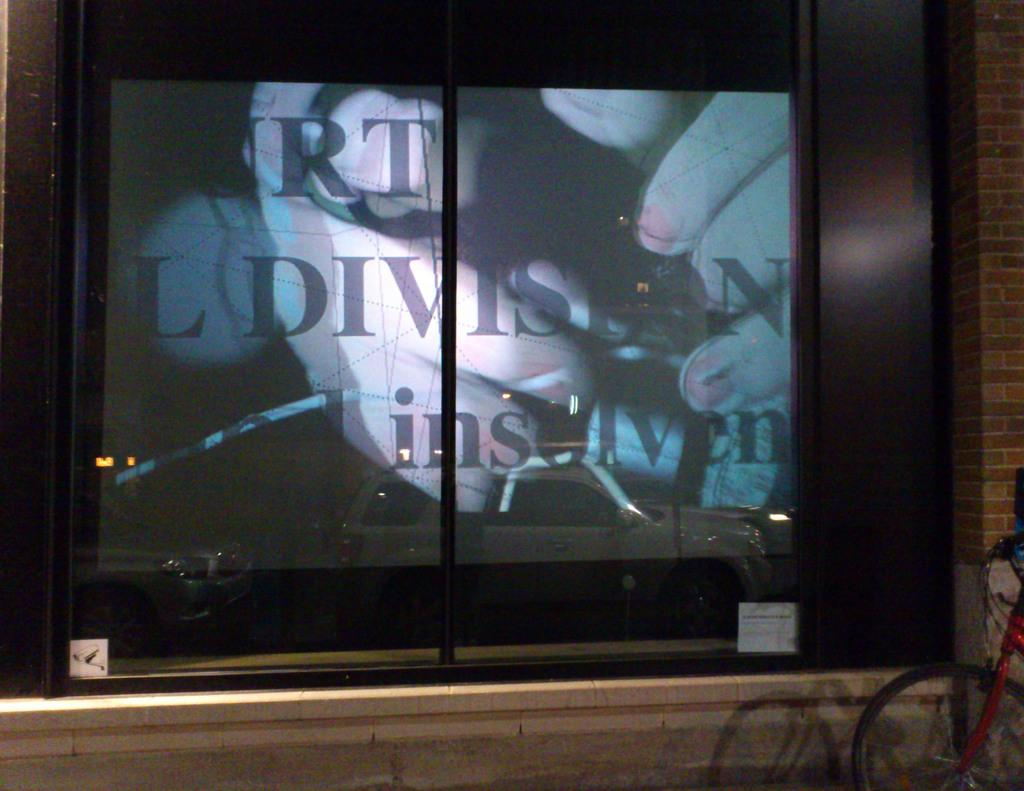<image>
Share a concise interpretation of the image provided. A sign in a building window advertises RT Division insolven. 